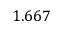<formula> <loc_0><loc_0><loc_500><loc_500>1 . 6 6 7</formula> 